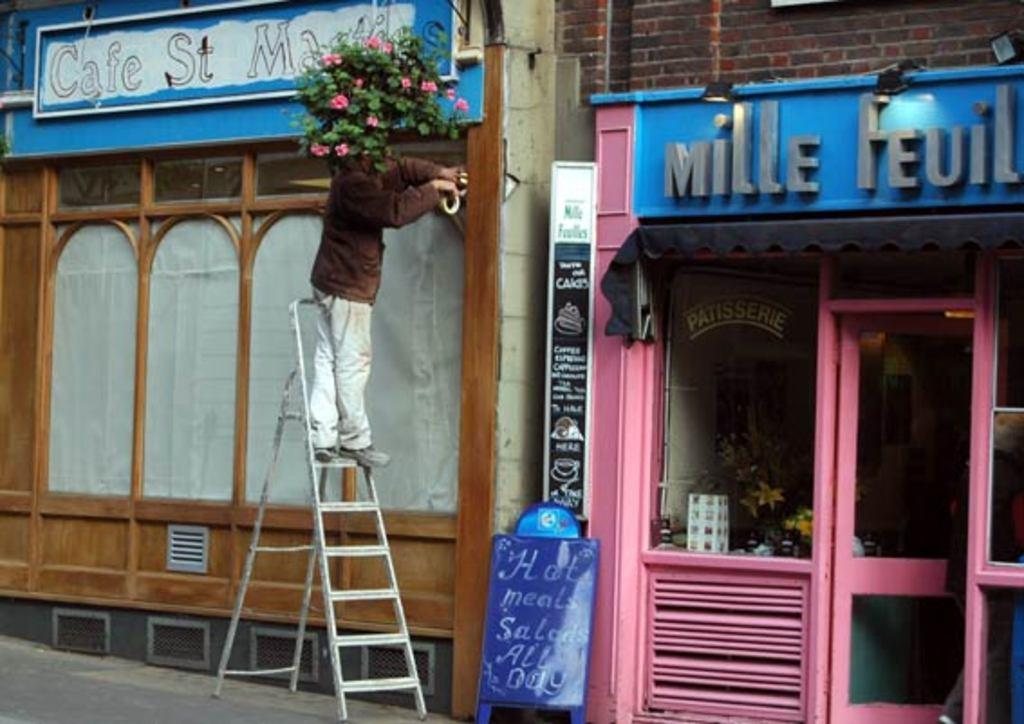<image>
Describe the image concisely. A man on a ladder outside of Cafe St. something. 